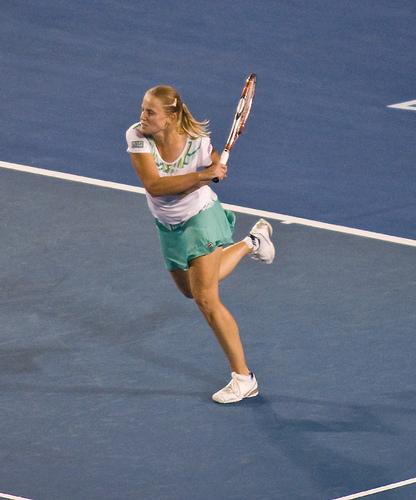What gender is this person?
Short answer required. Female. What sport is this?
Concise answer only. Tennis. What color are the woman's shoes?
Give a very brief answer. White. 